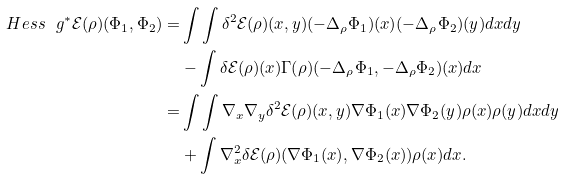<formula> <loc_0><loc_0><loc_500><loc_500>H e s s _ { \ } g ^ { * } \mathcal { E } ( \rho ) ( \Phi _ { 1 } , \Phi _ { 2 } ) = & \int \int \delta ^ { 2 } \mathcal { E } ( \rho ) ( x , y ) ( - \Delta _ { \rho } \Phi _ { 1 } ) ( x ) ( - \Delta _ { \rho } \Phi _ { 2 } ) ( y ) d x d y \\ & - \int \delta \mathcal { E } ( \rho ) ( x ) \Gamma ( \rho ) ( - \Delta _ { \rho } \Phi _ { 1 } , - \Delta _ { \rho } \Phi _ { 2 } ) ( x ) d x \\ = & \int \int \nabla _ { x } \nabla _ { y } \delta ^ { 2 } \mathcal { E } ( \rho ) ( x , y ) \nabla \Phi _ { 1 } ( x ) \nabla \Phi _ { 2 } ( y ) \rho ( x ) \rho ( y ) d x d y \\ & + \int \nabla _ { x } ^ { 2 } \delta \mathcal { E } ( \rho ) ( \nabla \Phi _ { 1 } ( x ) , \nabla \Phi _ { 2 } ( x ) ) \rho ( x ) d x .</formula> 